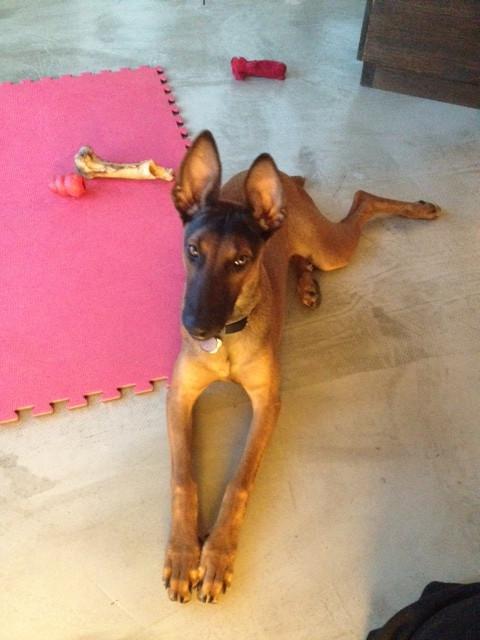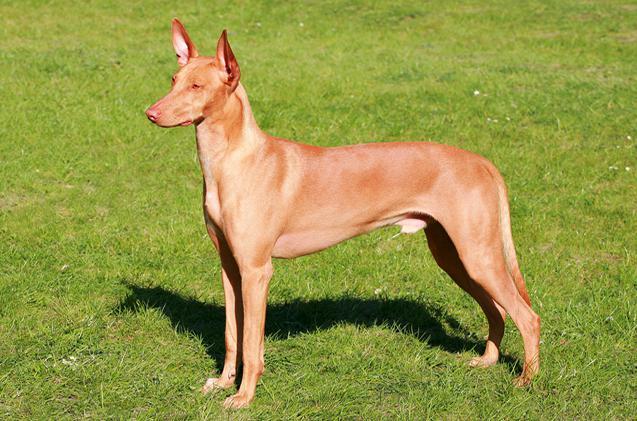The first image is the image on the left, the second image is the image on the right. For the images shown, is this caption "The left and right image contains the same number of dogs." true? Answer yes or no. Yes. The first image is the image on the left, the second image is the image on the right. For the images displayed, is the sentence "All the dogs are laying down." factually correct? Answer yes or no. No. 